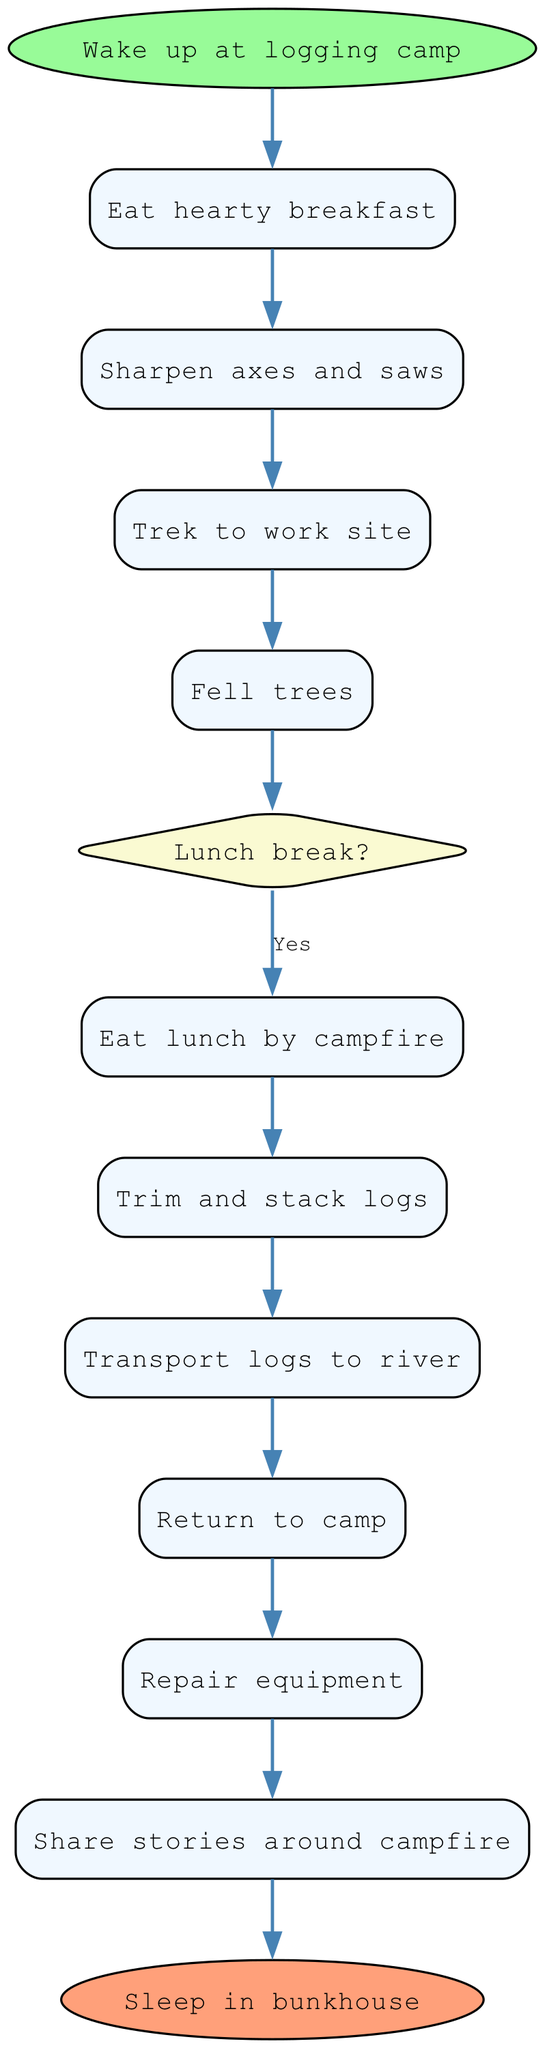What is the first activity in a logger's day? The first activity listed in the diagram is "Wake up at logging camp," as it is the initial point from which the other activities follow.
Answer: Wake up at logging camp How many activities are there in total? By counting the activities represented in the diagram, there are eight activities including the decision point. This can be verified by reviewing the sequential flow from the start to end nodes.
Answer: Eight What comes after eating lunch? After "Eat lunch by campfire," the next activity is "Trim and stack logs." This follows the flow from the decision point about the lunch break and leads into the subsequent tasks.
Answer: Trim and stack logs What is the last activity before sleeping in the bunkhouse? The last activity prior to "Sleep in bunkhouse" is "Share stories around campfire." This is determined by tracing back the steps leading to the end of the sequence.
Answer: Share stories around campfire Is there a decision point in the diagram related to lunch? Yes, the diagram includes a decision point labeled "Lunch break?" After the "Fell trees" activity, the flow diverges at this point.
Answer: Yes How many decision points are included in the diagram? The diagram has one decision point, which is "Lunch break?" This determines whether the logger takes a break for lunch or continues with work.
Answer: One What activity requires repair work? The activity "Repair equipment" comes after "Return to camp," indicating that it is a task focused on maintaining tools and machinery rather than logging itself.
Answer: Repair equipment What happens right after sharpening axes and saws? The activity that follows "Sharpen axes and saws" is "Trek to work site," showing the progression of preparing tools and then moving to the logging area.
Answer: Trek to work site How are logs transported according to the diagram? The logs are "Transport logs to river" as per the sequence outlined in the activity diagram, showing the process of moving logs after they have been felled and trimmed.
Answer: Transport logs to river 